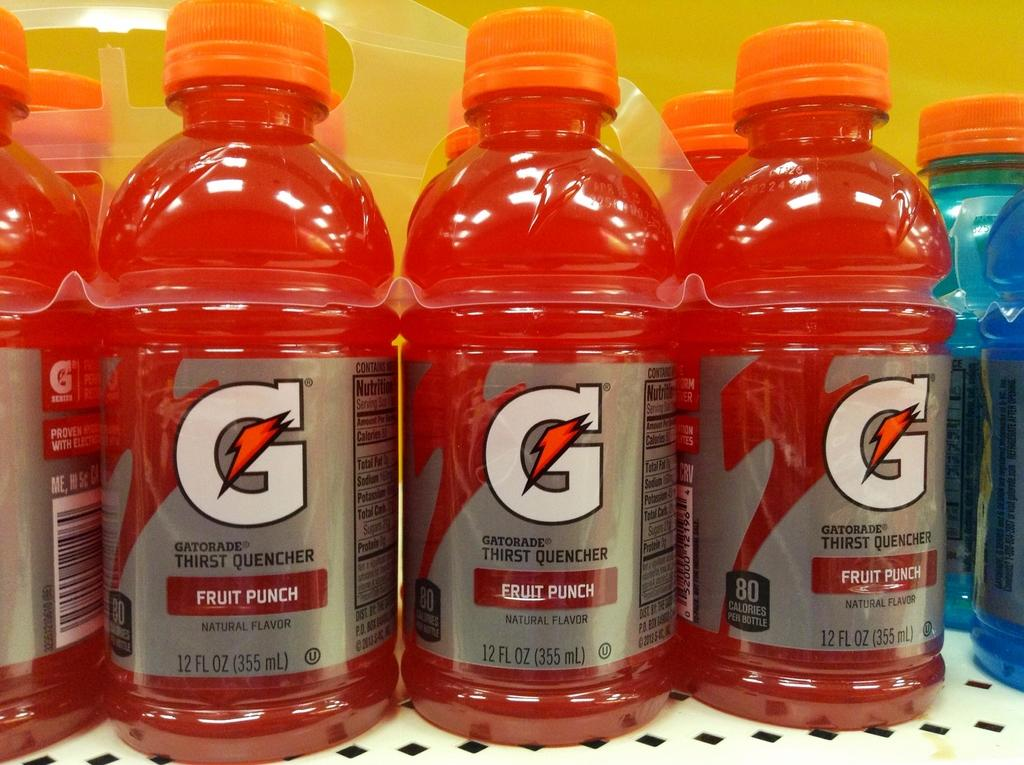<image>
Create a compact narrative representing the image presented. Red fruit punch Gatorade bottles are on a white, metal shelf. 